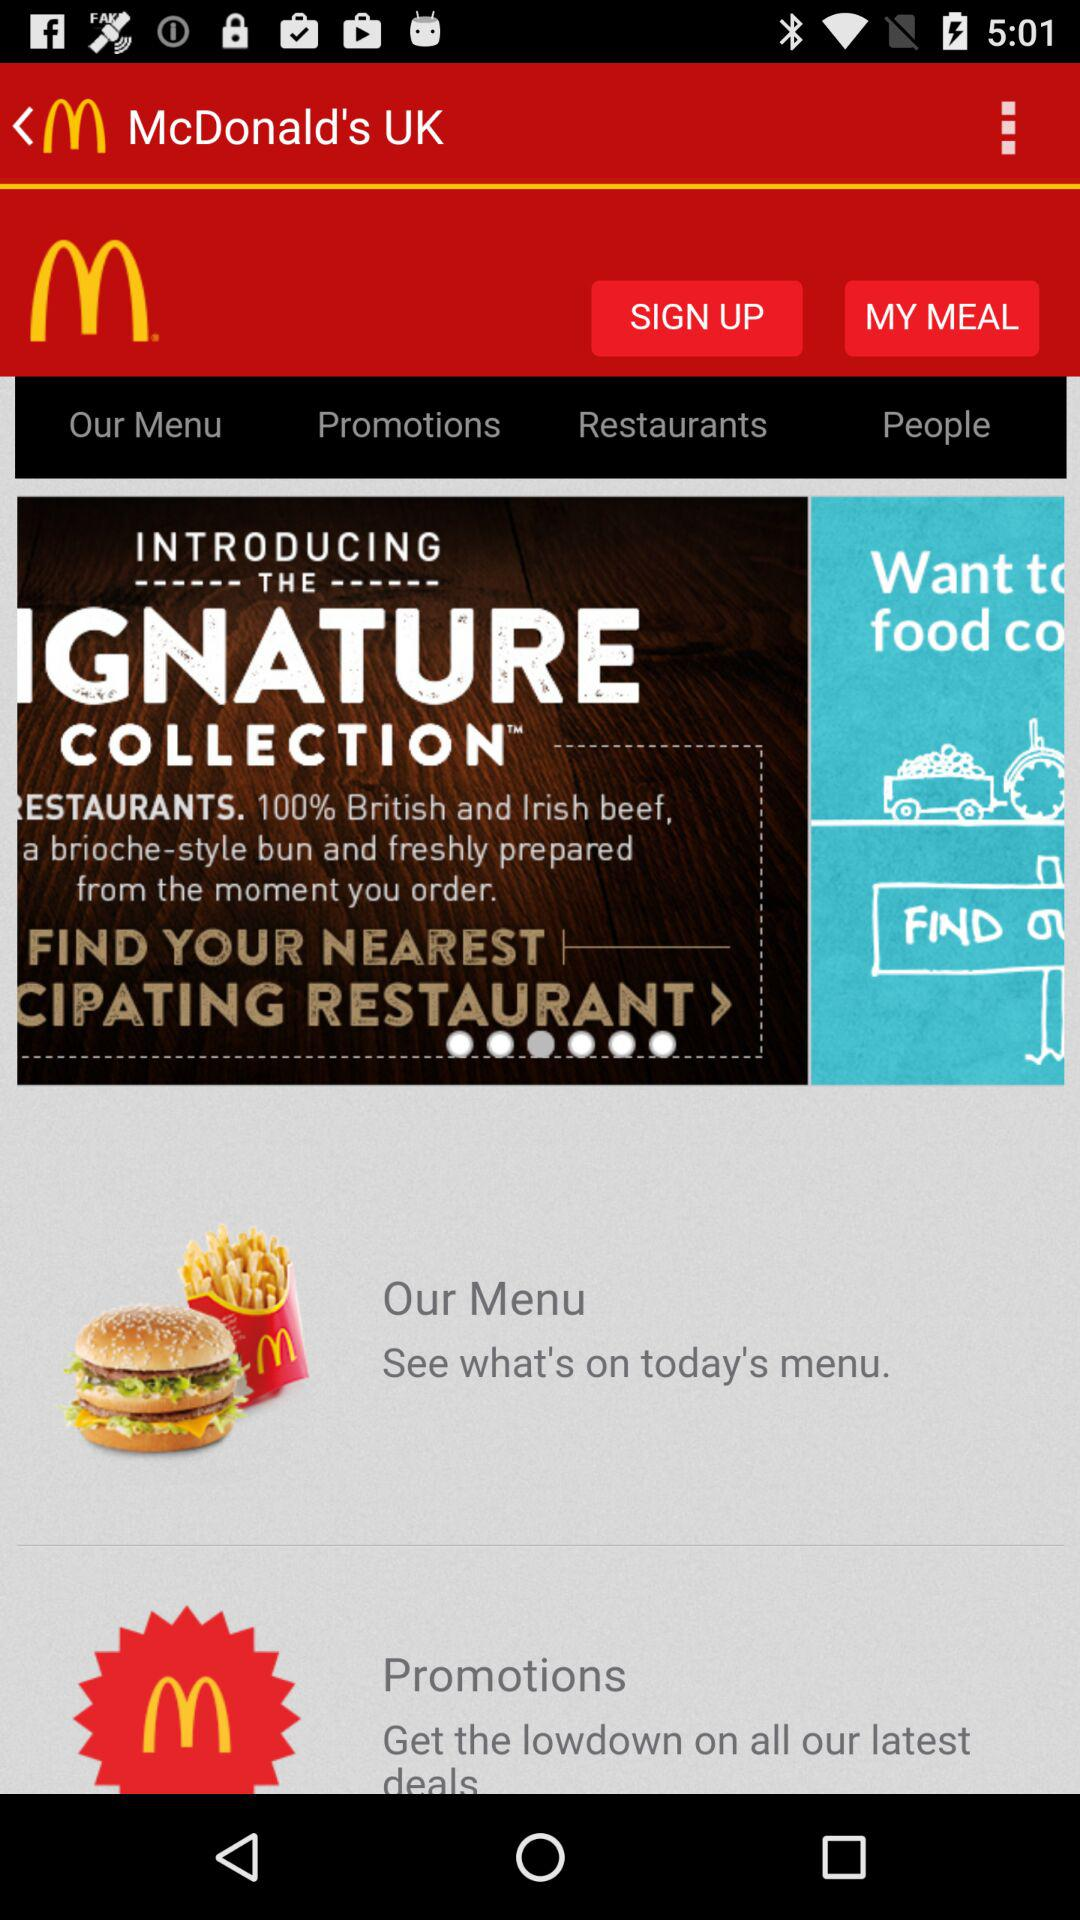What is the application name? The application name is "McDonald's UK". 